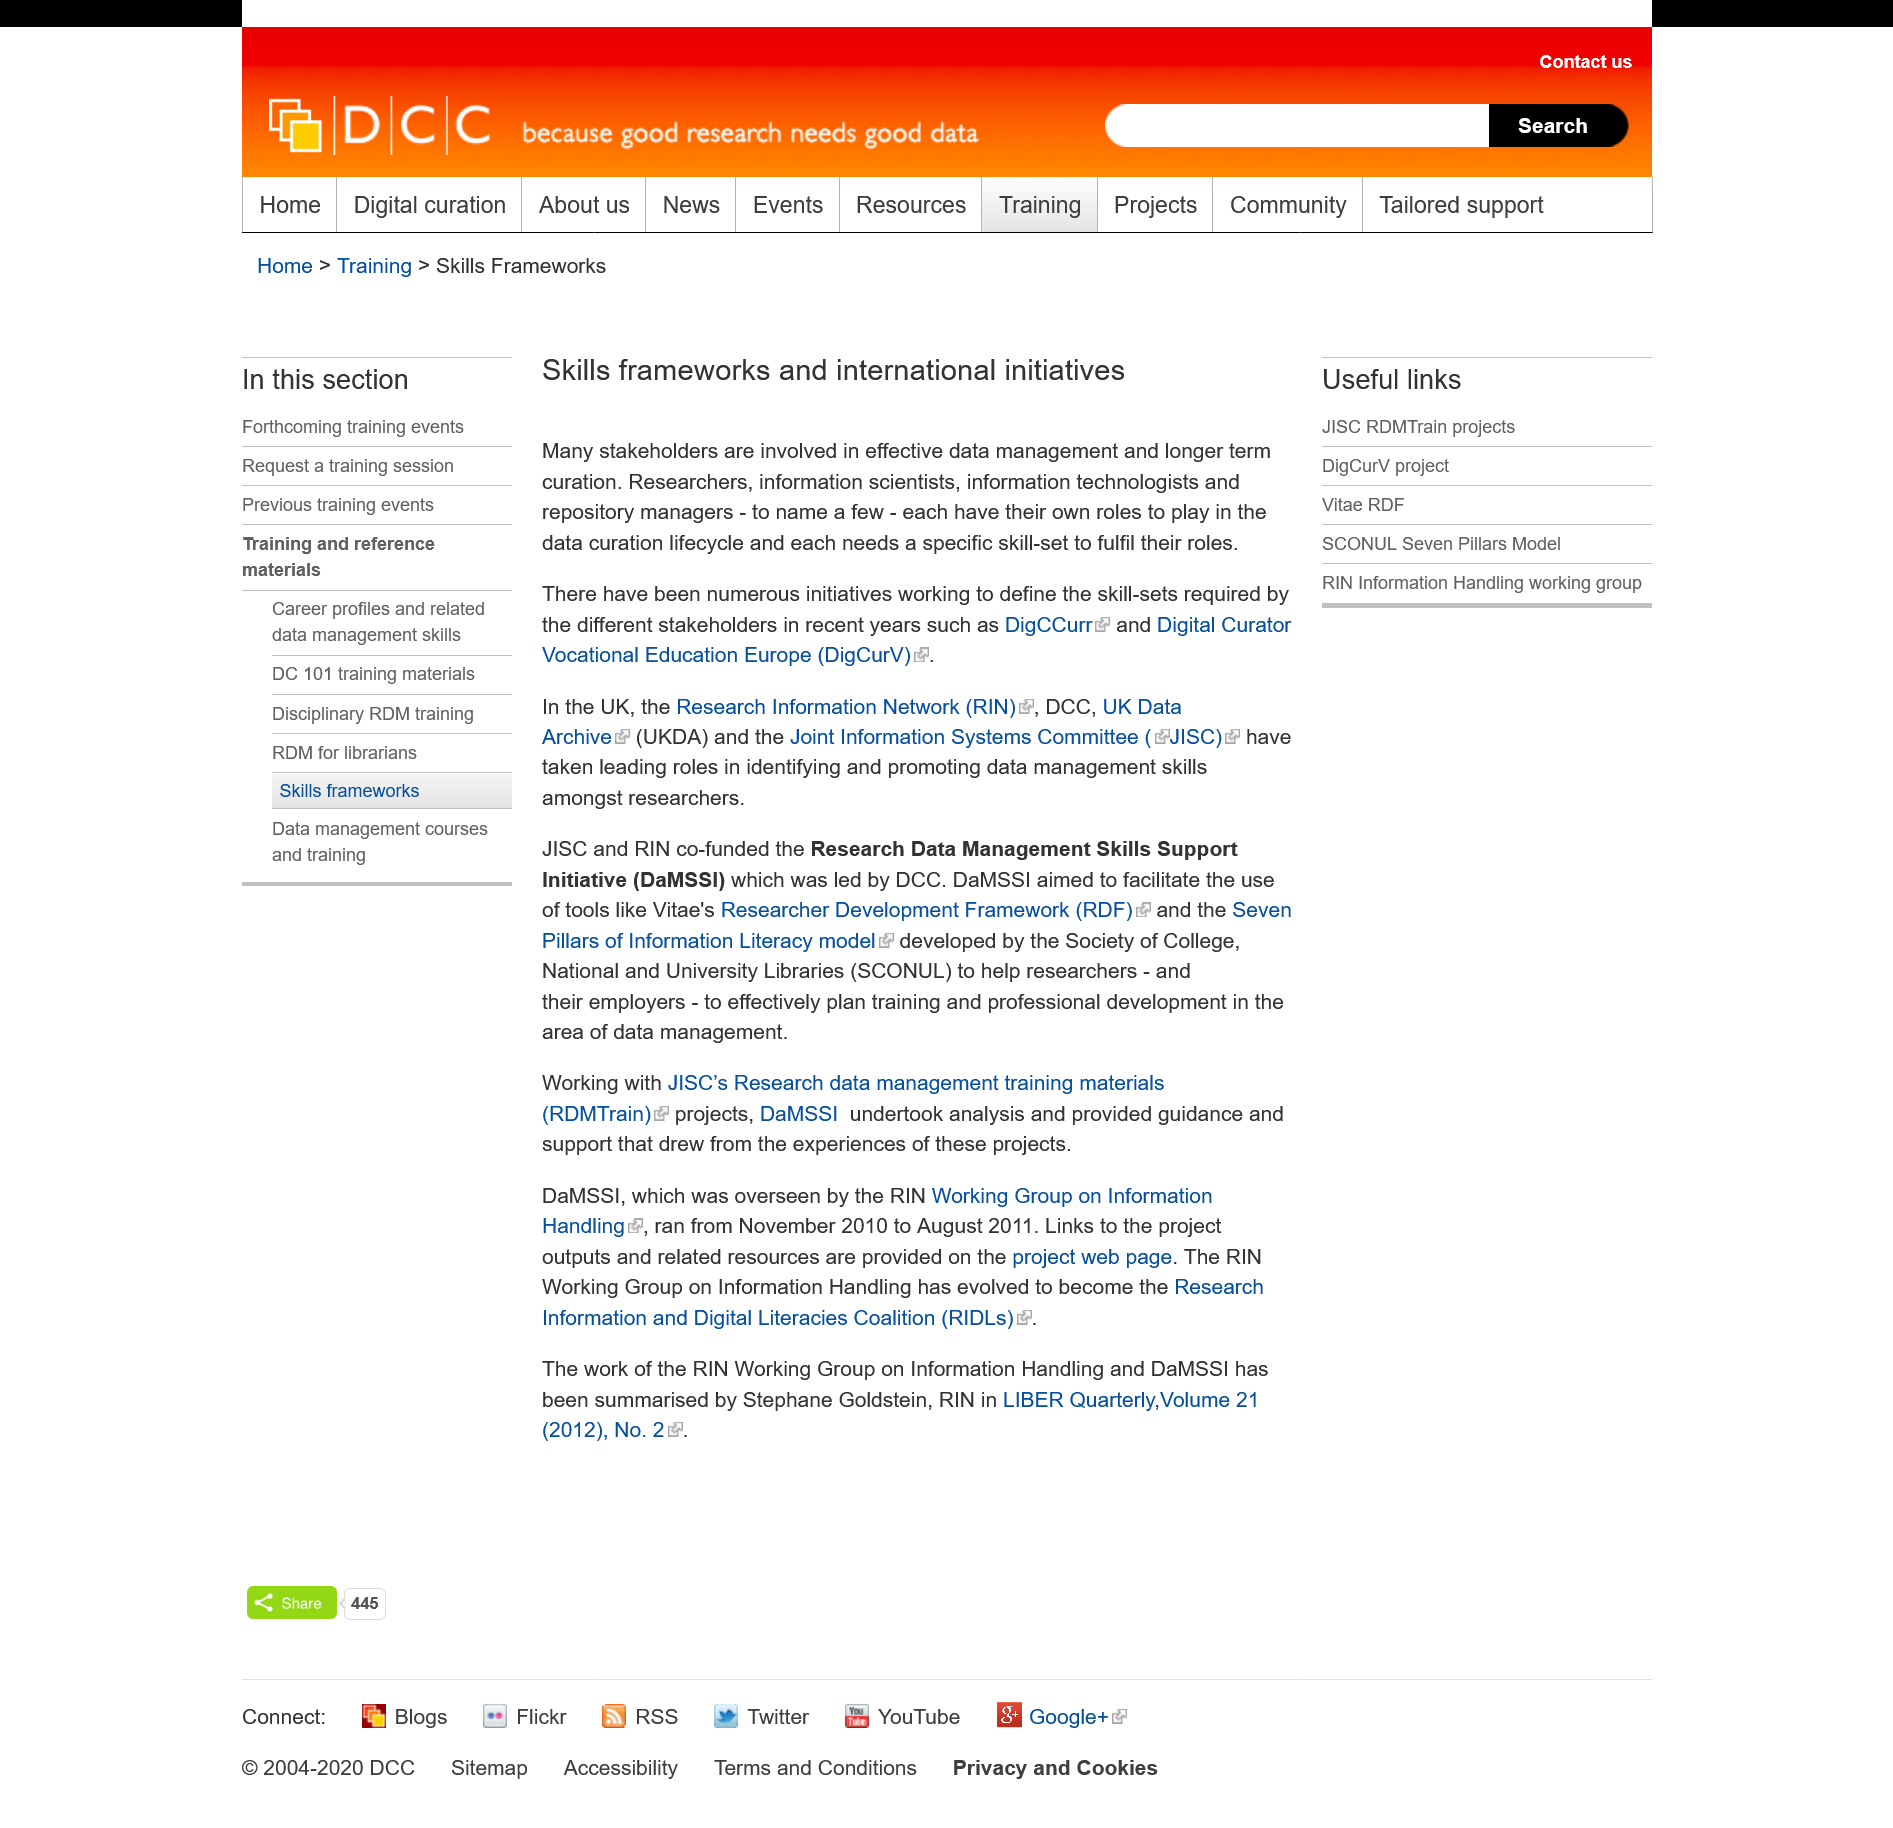Identify some key points in this picture. There are multiple stakeholders involved in effective data management and longer term curation. Data curation is a process that involves various occupations, each of which has its own specific role to play in the lifecycle of data. These occupations require specific skill-sets to fulfill their roles and contribute to the overall success of the data curation process. Skills frameworks and international initiatives have been working towards making them a requirement for stakeholders, including DigCCurr and Digital Curator Vocational Education Europe (DigCurV). 